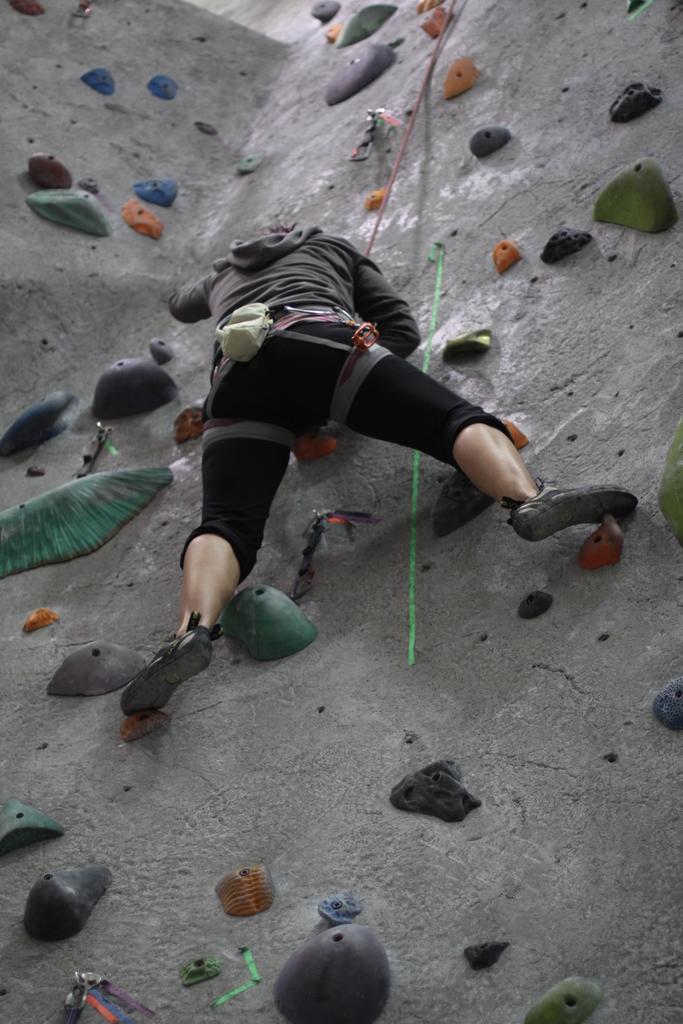How would you summarize this image in a sentence or two? In this image we can see a person climbing on the rock holding a rope. 